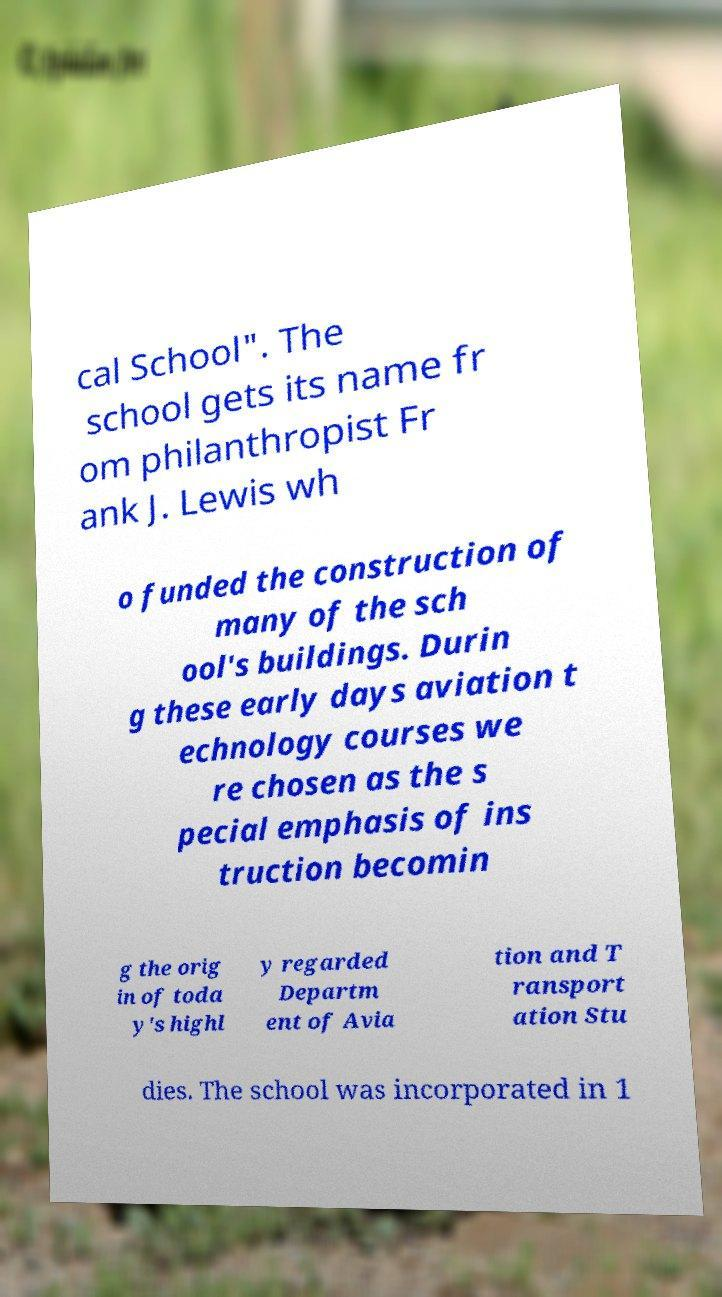Could you assist in decoding the text presented in this image and type it out clearly? cal School". The school gets its name fr om philanthropist Fr ank J. Lewis wh o funded the construction of many of the sch ool's buildings. Durin g these early days aviation t echnology courses we re chosen as the s pecial emphasis of ins truction becomin g the orig in of toda y's highl y regarded Departm ent of Avia tion and T ransport ation Stu dies. The school was incorporated in 1 